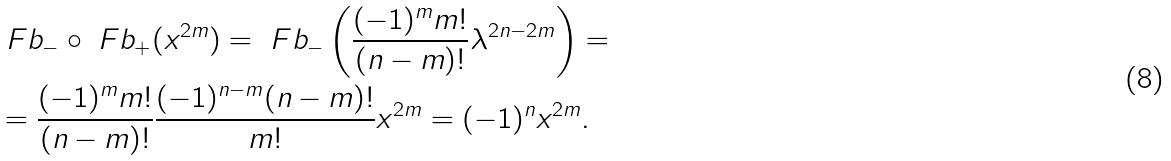Convert formula to latex. <formula><loc_0><loc_0><loc_500><loc_500>& \ F b _ { - } \circ \ F b _ { + } ( x ^ { 2 m } ) = \ F b _ { - } \left ( \frac { ( - 1 ) ^ { m } m ! } { ( n - m ) ! } \lambda ^ { 2 n - 2 m } \right ) = \\ & = \frac { ( - 1 ) ^ { m } m ! } { ( n - m ) ! } \frac { ( - 1 ) ^ { n - m } ( n - m ) ! } { m ! } x ^ { 2 m } = ( - 1 ) ^ { n } x ^ { 2 m } .</formula> 